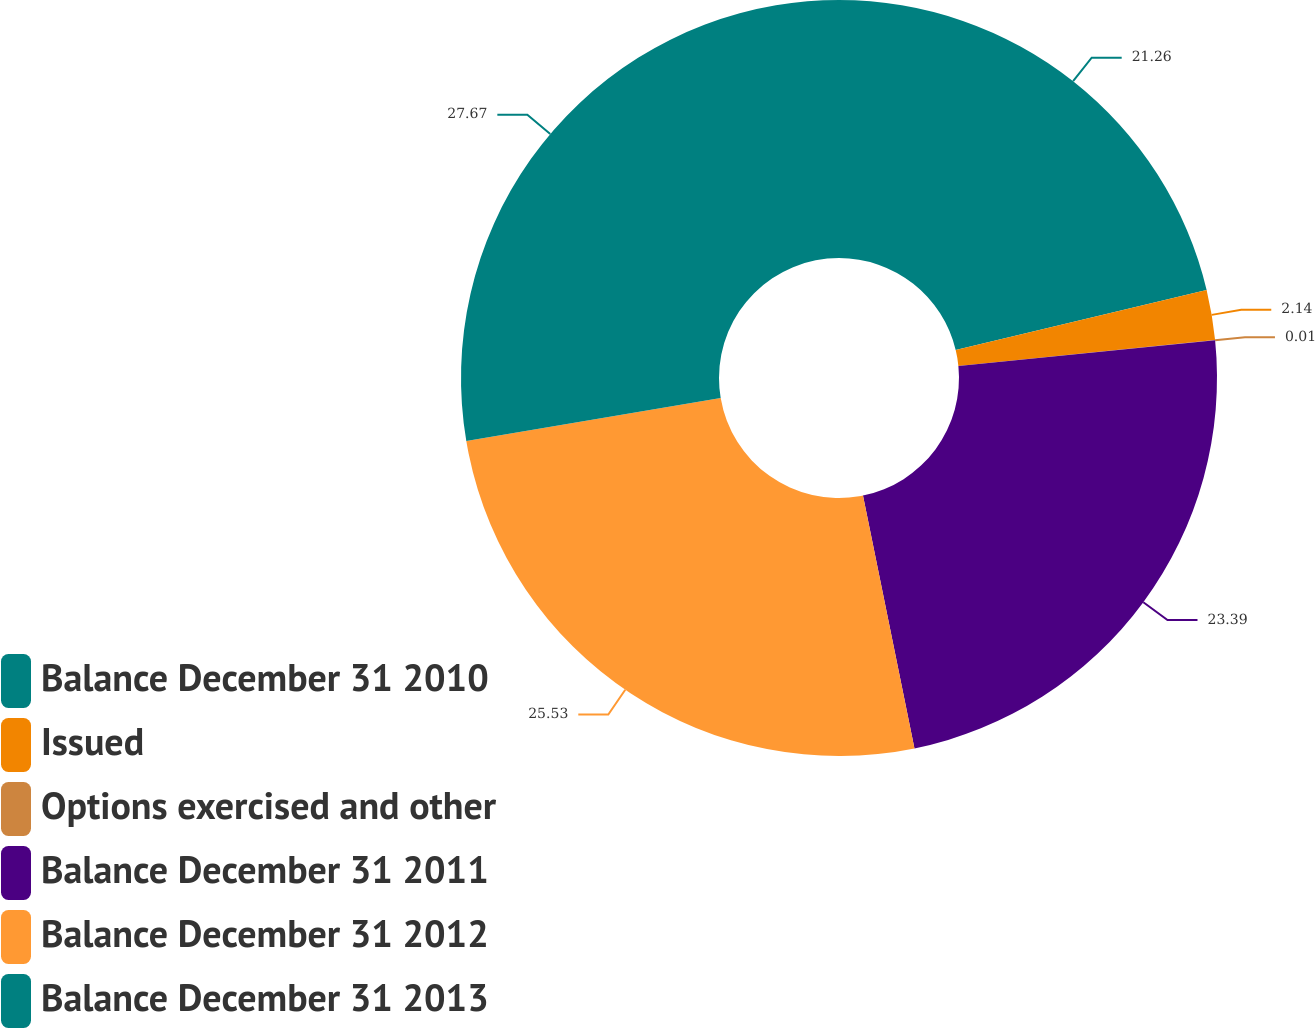<chart> <loc_0><loc_0><loc_500><loc_500><pie_chart><fcel>Balance December 31 2010<fcel>Issued<fcel>Options exercised and other<fcel>Balance December 31 2011<fcel>Balance December 31 2012<fcel>Balance December 31 2013<nl><fcel>21.26%<fcel>2.14%<fcel>0.01%<fcel>23.39%<fcel>25.53%<fcel>27.67%<nl></chart> 